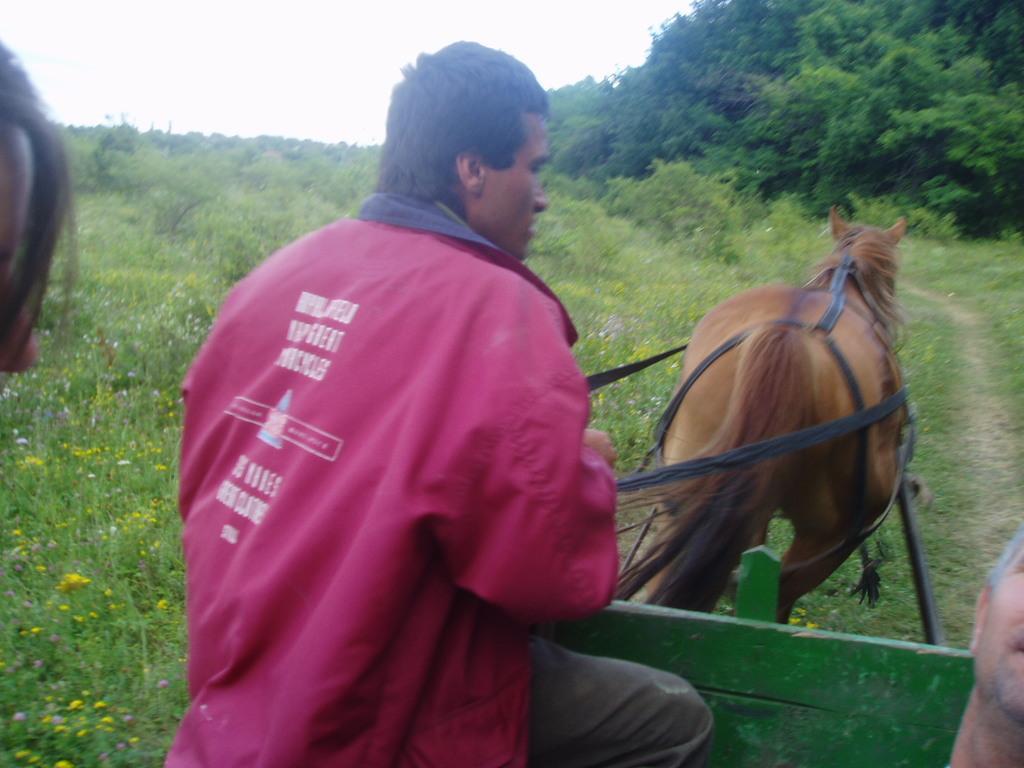Describe this image in one or two sentences. A man with pink jacket is sitting on the cart and riding a horse. In front of him there are some trees. And to the left side we can see some grass. 